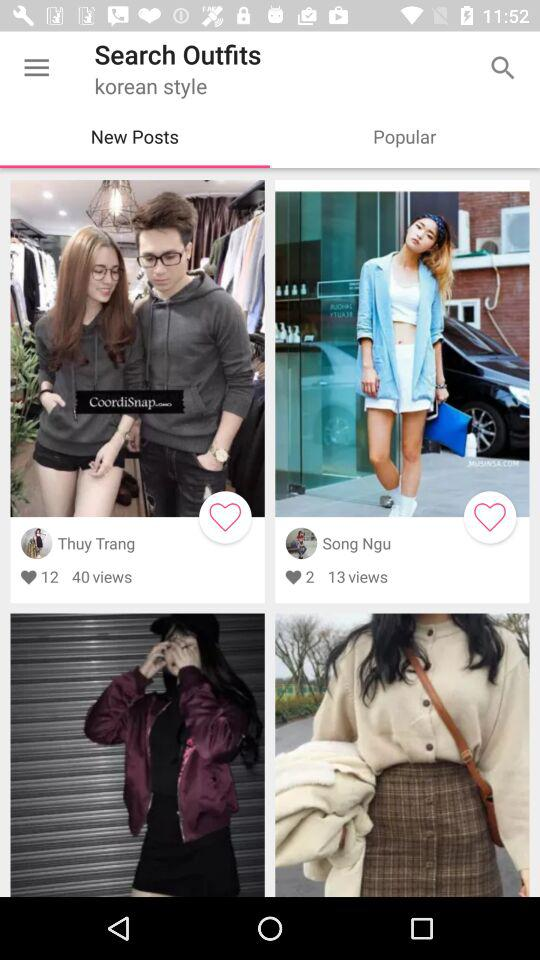How many likes on Thuy Trang's post? There are 12 likes on Thuy Trang's post. 